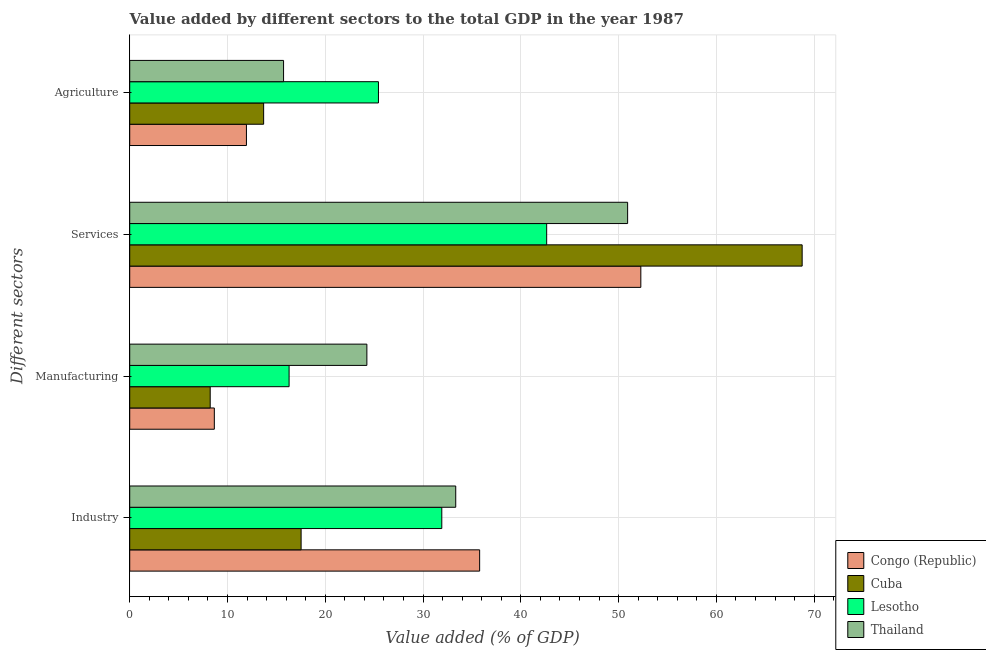How many different coloured bars are there?
Your answer should be very brief. 4. How many groups of bars are there?
Your answer should be very brief. 4. Are the number of bars on each tick of the Y-axis equal?
Your answer should be very brief. Yes. What is the label of the 4th group of bars from the top?
Ensure brevity in your answer.  Industry. What is the value added by agricultural sector in Cuba?
Offer a terse response. 13.7. Across all countries, what is the maximum value added by agricultural sector?
Offer a terse response. 25.44. Across all countries, what is the minimum value added by manufacturing sector?
Your response must be concise. 8.23. In which country was the value added by manufacturing sector maximum?
Offer a terse response. Thailand. In which country was the value added by industrial sector minimum?
Your answer should be compact. Cuba. What is the total value added by manufacturing sector in the graph?
Provide a succinct answer. 57.44. What is the difference between the value added by agricultural sector in Thailand and that in Lesotho?
Keep it short and to the point. -9.71. What is the difference between the value added by industrial sector in Cuba and the value added by manufacturing sector in Thailand?
Your answer should be compact. -6.73. What is the average value added by manufacturing sector per country?
Your response must be concise. 14.36. What is the difference between the value added by agricultural sector and value added by industrial sector in Lesotho?
Your answer should be compact. -6.48. What is the ratio of the value added by services sector in Thailand to that in Lesotho?
Make the answer very short. 1.19. Is the difference between the value added by services sector in Congo (Republic) and Thailand greater than the difference between the value added by manufacturing sector in Congo (Republic) and Thailand?
Provide a succinct answer. Yes. What is the difference between the highest and the second highest value added by industrial sector?
Your answer should be very brief. 2.45. What is the difference between the highest and the lowest value added by agricultural sector?
Your answer should be compact. 13.5. Is the sum of the value added by manufacturing sector in Cuba and Lesotho greater than the maximum value added by services sector across all countries?
Make the answer very short. No. Is it the case that in every country, the sum of the value added by manufacturing sector and value added by agricultural sector is greater than the sum of value added by services sector and value added by industrial sector?
Offer a very short reply. No. What does the 2nd bar from the top in Industry represents?
Provide a succinct answer. Lesotho. What does the 2nd bar from the bottom in Manufacturing represents?
Offer a very short reply. Cuba. Is it the case that in every country, the sum of the value added by industrial sector and value added by manufacturing sector is greater than the value added by services sector?
Offer a terse response. No. Are the values on the major ticks of X-axis written in scientific E-notation?
Ensure brevity in your answer.  No. Does the graph contain any zero values?
Provide a short and direct response. No. Does the graph contain grids?
Provide a short and direct response. Yes. Where does the legend appear in the graph?
Your response must be concise. Bottom right. How many legend labels are there?
Ensure brevity in your answer.  4. How are the legend labels stacked?
Your answer should be very brief. Vertical. What is the title of the graph?
Your answer should be compact. Value added by different sectors to the total GDP in the year 1987. Does "Kazakhstan" appear as one of the legend labels in the graph?
Your response must be concise. No. What is the label or title of the X-axis?
Make the answer very short. Value added (% of GDP). What is the label or title of the Y-axis?
Make the answer very short. Different sectors. What is the Value added (% of GDP) in Congo (Republic) in Industry?
Provide a short and direct response. 35.79. What is the Value added (% of GDP) in Cuba in Industry?
Provide a short and direct response. 17.53. What is the Value added (% of GDP) of Lesotho in Industry?
Offer a very short reply. 31.92. What is the Value added (% of GDP) of Thailand in Industry?
Keep it short and to the point. 33.34. What is the Value added (% of GDP) in Congo (Republic) in Manufacturing?
Make the answer very short. 8.65. What is the Value added (% of GDP) in Cuba in Manufacturing?
Ensure brevity in your answer.  8.23. What is the Value added (% of GDP) in Lesotho in Manufacturing?
Offer a very short reply. 16.3. What is the Value added (% of GDP) in Thailand in Manufacturing?
Provide a short and direct response. 24.25. What is the Value added (% of GDP) of Congo (Republic) in Services?
Your answer should be compact. 52.27. What is the Value added (% of GDP) in Cuba in Services?
Your answer should be compact. 68.77. What is the Value added (% of GDP) of Lesotho in Services?
Ensure brevity in your answer.  42.64. What is the Value added (% of GDP) in Thailand in Services?
Keep it short and to the point. 50.92. What is the Value added (% of GDP) in Congo (Republic) in Agriculture?
Offer a very short reply. 11.94. What is the Value added (% of GDP) of Cuba in Agriculture?
Offer a terse response. 13.7. What is the Value added (% of GDP) of Lesotho in Agriculture?
Keep it short and to the point. 25.44. What is the Value added (% of GDP) of Thailand in Agriculture?
Keep it short and to the point. 15.73. Across all Different sectors, what is the maximum Value added (% of GDP) in Congo (Republic)?
Offer a terse response. 52.27. Across all Different sectors, what is the maximum Value added (% of GDP) in Cuba?
Keep it short and to the point. 68.77. Across all Different sectors, what is the maximum Value added (% of GDP) in Lesotho?
Make the answer very short. 42.64. Across all Different sectors, what is the maximum Value added (% of GDP) of Thailand?
Your answer should be compact. 50.92. Across all Different sectors, what is the minimum Value added (% of GDP) of Congo (Republic)?
Offer a terse response. 8.65. Across all Different sectors, what is the minimum Value added (% of GDP) of Cuba?
Your response must be concise. 8.23. Across all Different sectors, what is the minimum Value added (% of GDP) of Lesotho?
Offer a terse response. 16.3. Across all Different sectors, what is the minimum Value added (% of GDP) in Thailand?
Your answer should be very brief. 15.73. What is the total Value added (% of GDP) in Congo (Republic) in the graph?
Ensure brevity in your answer.  108.65. What is the total Value added (% of GDP) in Cuba in the graph?
Ensure brevity in your answer.  108.23. What is the total Value added (% of GDP) in Lesotho in the graph?
Provide a succinct answer. 116.3. What is the total Value added (% of GDP) of Thailand in the graph?
Your response must be concise. 124.25. What is the difference between the Value added (% of GDP) in Congo (Republic) in Industry and that in Manufacturing?
Your answer should be very brief. 27.13. What is the difference between the Value added (% of GDP) in Cuba in Industry and that in Manufacturing?
Make the answer very short. 9.3. What is the difference between the Value added (% of GDP) of Lesotho in Industry and that in Manufacturing?
Your answer should be compact. 15.62. What is the difference between the Value added (% of GDP) of Thailand in Industry and that in Manufacturing?
Ensure brevity in your answer.  9.09. What is the difference between the Value added (% of GDP) of Congo (Republic) in Industry and that in Services?
Provide a succinct answer. -16.49. What is the difference between the Value added (% of GDP) of Cuba in Industry and that in Services?
Your answer should be very brief. -51.24. What is the difference between the Value added (% of GDP) of Lesotho in Industry and that in Services?
Your response must be concise. -10.73. What is the difference between the Value added (% of GDP) in Thailand in Industry and that in Services?
Offer a very short reply. -17.58. What is the difference between the Value added (% of GDP) of Congo (Republic) in Industry and that in Agriculture?
Offer a very short reply. 23.85. What is the difference between the Value added (% of GDP) in Cuba in Industry and that in Agriculture?
Give a very brief answer. 3.83. What is the difference between the Value added (% of GDP) in Lesotho in Industry and that in Agriculture?
Keep it short and to the point. 6.48. What is the difference between the Value added (% of GDP) of Thailand in Industry and that in Agriculture?
Give a very brief answer. 17.61. What is the difference between the Value added (% of GDP) in Congo (Republic) in Manufacturing and that in Services?
Give a very brief answer. -43.62. What is the difference between the Value added (% of GDP) in Cuba in Manufacturing and that in Services?
Offer a very short reply. -60.54. What is the difference between the Value added (% of GDP) in Lesotho in Manufacturing and that in Services?
Keep it short and to the point. -26.34. What is the difference between the Value added (% of GDP) of Thailand in Manufacturing and that in Services?
Provide a short and direct response. -26.67. What is the difference between the Value added (% of GDP) in Congo (Republic) in Manufacturing and that in Agriculture?
Your answer should be very brief. -3.28. What is the difference between the Value added (% of GDP) in Cuba in Manufacturing and that in Agriculture?
Your response must be concise. -5.47. What is the difference between the Value added (% of GDP) of Lesotho in Manufacturing and that in Agriculture?
Provide a succinct answer. -9.14. What is the difference between the Value added (% of GDP) of Thailand in Manufacturing and that in Agriculture?
Make the answer very short. 8.52. What is the difference between the Value added (% of GDP) in Congo (Republic) in Services and that in Agriculture?
Your answer should be compact. 40.34. What is the difference between the Value added (% of GDP) of Cuba in Services and that in Agriculture?
Give a very brief answer. 55.08. What is the difference between the Value added (% of GDP) of Lesotho in Services and that in Agriculture?
Offer a very short reply. 17.21. What is the difference between the Value added (% of GDP) in Thailand in Services and that in Agriculture?
Ensure brevity in your answer.  35.19. What is the difference between the Value added (% of GDP) of Congo (Republic) in Industry and the Value added (% of GDP) of Cuba in Manufacturing?
Ensure brevity in your answer.  27.56. What is the difference between the Value added (% of GDP) in Congo (Republic) in Industry and the Value added (% of GDP) in Lesotho in Manufacturing?
Your response must be concise. 19.49. What is the difference between the Value added (% of GDP) of Congo (Republic) in Industry and the Value added (% of GDP) of Thailand in Manufacturing?
Offer a terse response. 11.53. What is the difference between the Value added (% of GDP) of Cuba in Industry and the Value added (% of GDP) of Lesotho in Manufacturing?
Offer a very short reply. 1.23. What is the difference between the Value added (% of GDP) in Cuba in Industry and the Value added (% of GDP) in Thailand in Manufacturing?
Provide a succinct answer. -6.73. What is the difference between the Value added (% of GDP) of Lesotho in Industry and the Value added (% of GDP) of Thailand in Manufacturing?
Provide a succinct answer. 7.66. What is the difference between the Value added (% of GDP) in Congo (Republic) in Industry and the Value added (% of GDP) in Cuba in Services?
Ensure brevity in your answer.  -32.99. What is the difference between the Value added (% of GDP) of Congo (Republic) in Industry and the Value added (% of GDP) of Lesotho in Services?
Provide a short and direct response. -6.86. What is the difference between the Value added (% of GDP) of Congo (Republic) in Industry and the Value added (% of GDP) of Thailand in Services?
Provide a succinct answer. -15.14. What is the difference between the Value added (% of GDP) of Cuba in Industry and the Value added (% of GDP) of Lesotho in Services?
Offer a terse response. -25.11. What is the difference between the Value added (% of GDP) of Cuba in Industry and the Value added (% of GDP) of Thailand in Services?
Provide a short and direct response. -33.39. What is the difference between the Value added (% of GDP) in Lesotho in Industry and the Value added (% of GDP) in Thailand in Services?
Ensure brevity in your answer.  -19.01. What is the difference between the Value added (% of GDP) of Congo (Republic) in Industry and the Value added (% of GDP) of Cuba in Agriculture?
Provide a short and direct response. 22.09. What is the difference between the Value added (% of GDP) in Congo (Republic) in Industry and the Value added (% of GDP) in Lesotho in Agriculture?
Your answer should be very brief. 10.35. What is the difference between the Value added (% of GDP) in Congo (Republic) in Industry and the Value added (% of GDP) in Thailand in Agriculture?
Your answer should be very brief. 20.05. What is the difference between the Value added (% of GDP) in Cuba in Industry and the Value added (% of GDP) in Lesotho in Agriculture?
Provide a succinct answer. -7.91. What is the difference between the Value added (% of GDP) in Cuba in Industry and the Value added (% of GDP) in Thailand in Agriculture?
Your answer should be compact. 1.8. What is the difference between the Value added (% of GDP) of Lesotho in Industry and the Value added (% of GDP) of Thailand in Agriculture?
Your response must be concise. 16.18. What is the difference between the Value added (% of GDP) in Congo (Republic) in Manufacturing and the Value added (% of GDP) in Cuba in Services?
Your response must be concise. -60.12. What is the difference between the Value added (% of GDP) of Congo (Republic) in Manufacturing and the Value added (% of GDP) of Lesotho in Services?
Keep it short and to the point. -33.99. What is the difference between the Value added (% of GDP) of Congo (Republic) in Manufacturing and the Value added (% of GDP) of Thailand in Services?
Your answer should be compact. -42.27. What is the difference between the Value added (% of GDP) of Cuba in Manufacturing and the Value added (% of GDP) of Lesotho in Services?
Offer a very short reply. -34.41. What is the difference between the Value added (% of GDP) of Cuba in Manufacturing and the Value added (% of GDP) of Thailand in Services?
Ensure brevity in your answer.  -42.69. What is the difference between the Value added (% of GDP) in Lesotho in Manufacturing and the Value added (% of GDP) in Thailand in Services?
Provide a succinct answer. -34.62. What is the difference between the Value added (% of GDP) in Congo (Republic) in Manufacturing and the Value added (% of GDP) in Cuba in Agriculture?
Offer a terse response. -5.04. What is the difference between the Value added (% of GDP) in Congo (Republic) in Manufacturing and the Value added (% of GDP) in Lesotho in Agriculture?
Provide a short and direct response. -16.79. What is the difference between the Value added (% of GDP) of Congo (Republic) in Manufacturing and the Value added (% of GDP) of Thailand in Agriculture?
Your response must be concise. -7.08. What is the difference between the Value added (% of GDP) of Cuba in Manufacturing and the Value added (% of GDP) of Lesotho in Agriculture?
Your response must be concise. -17.21. What is the difference between the Value added (% of GDP) in Cuba in Manufacturing and the Value added (% of GDP) in Thailand in Agriculture?
Provide a short and direct response. -7.5. What is the difference between the Value added (% of GDP) of Lesotho in Manufacturing and the Value added (% of GDP) of Thailand in Agriculture?
Give a very brief answer. 0.57. What is the difference between the Value added (% of GDP) of Congo (Republic) in Services and the Value added (% of GDP) of Cuba in Agriculture?
Your response must be concise. 38.58. What is the difference between the Value added (% of GDP) of Congo (Republic) in Services and the Value added (% of GDP) of Lesotho in Agriculture?
Make the answer very short. 26.84. What is the difference between the Value added (% of GDP) of Congo (Republic) in Services and the Value added (% of GDP) of Thailand in Agriculture?
Ensure brevity in your answer.  36.54. What is the difference between the Value added (% of GDP) in Cuba in Services and the Value added (% of GDP) in Lesotho in Agriculture?
Keep it short and to the point. 43.34. What is the difference between the Value added (% of GDP) of Cuba in Services and the Value added (% of GDP) of Thailand in Agriculture?
Offer a very short reply. 53.04. What is the difference between the Value added (% of GDP) of Lesotho in Services and the Value added (% of GDP) of Thailand in Agriculture?
Offer a terse response. 26.91. What is the average Value added (% of GDP) of Congo (Republic) per Different sectors?
Your answer should be compact. 27.16. What is the average Value added (% of GDP) in Cuba per Different sectors?
Your answer should be very brief. 27.06. What is the average Value added (% of GDP) in Lesotho per Different sectors?
Keep it short and to the point. 29.08. What is the average Value added (% of GDP) in Thailand per Different sectors?
Offer a very short reply. 31.06. What is the difference between the Value added (% of GDP) in Congo (Republic) and Value added (% of GDP) in Cuba in Industry?
Give a very brief answer. 18.26. What is the difference between the Value added (% of GDP) of Congo (Republic) and Value added (% of GDP) of Lesotho in Industry?
Your answer should be compact. 3.87. What is the difference between the Value added (% of GDP) in Congo (Republic) and Value added (% of GDP) in Thailand in Industry?
Your answer should be very brief. 2.45. What is the difference between the Value added (% of GDP) in Cuba and Value added (% of GDP) in Lesotho in Industry?
Your answer should be compact. -14.39. What is the difference between the Value added (% of GDP) of Cuba and Value added (% of GDP) of Thailand in Industry?
Make the answer very short. -15.81. What is the difference between the Value added (% of GDP) of Lesotho and Value added (% of GDP) of Thailand in Industry?
Make the answer very short. -1.43. What is the difference between the Value added (% of GDP) of Congo (Republic) and Value added (% of GDP) of Cuba in Manufacturing?
Ensure brevity in your answer.  0.42. What is the difference between the Value added (% of GDP) of Congo (Republic) and Value added (% of GDP) of Lesotho in Manufacturing?
Give a very brief answer. -7.65. What is the difference between the Value added (% of GDP) in Congo (Republic) and Value added (% of GDP) in Thailand in Manufacturing?
Ensure brevity in your answer.  -15.6. What is the difference between the Value added (% of GDP) of Cuba and Value added (% of GDP) of Lesotho in Manufacturing?
Provide a short and direct response. -8.07. What is the difference between the Value added (% of GDP) in Cuba and Value added (% of GDP) in Thailand in Manufacturing?
Provide a short and direct response. -16.02. What is the difference between the Value added (% of GDP) of Lesotho and Value added (% of GDP) of Thailand in Manufacturing?
Provide a short and direct response. -7.95. What is the difference between the Value added (% of GDP) in Congo (Republic) and Value added (% of GDP) in Cuba in Services?
Give a very brief answer. -16.5. What is the difference between the Value added (% of GDP) in Congo (Republic) and Value added (% of GDP) in Lesotho in Services?
Make the answer very short. 9.63. What is the difference between the Value added (% of GDP) in Congo (Republic) and Value added (% of GDP) in Thailand in Services?
Offer a terse response. 1.35. What is the difference between the Value added (% of GDP) of Cuba and Value added (% of GDP) of Lesotho in Services?
Provide a short and direct response. 26.13. What is the difference between the Value added (% of GDP) in Cuba and Value added (% of GDP) in Thailand in Services?
Make the answer very short. 17.85. What is the difference between the Value added (% of GDP) in Lesotho and Value added (% of GDP) in Thailand in Services?
Your answer should be very brief. -8.28. What is the difference between the Value added (% of GDP) in Congo (Republic) and Value added (% of GDP) in Cuba in Agriculture?
Offer a terse response. -1.76. What is the difference between the Value added (% of GDP) in Congo (Republic) and Value added (% of GDP) in Lesotho in Agriculture?
Give a very brief answer. -13.5. What is the difference between the Value added (% of GDP) in Congo (Republic) and Value added (% of GDP) in Thailand in Agriculture?
Provide a succinct answer. -3.8. What is the difference between the Value added (% of GDP) of Cuba and Value added (% of GDP) of Lesotho in Agriculture?
Provide a short and direct response. -11.74. What is the difference between the Value added (% of GDP) in Cuba and Value added (% of GDP) in Thailand in Agriculture?
Keep it short and to the point. -2.04. What is the difference between the Value added (% of GDP) of Lesotho and Value added (% of GDP) of Thailand in Agriculture?
Give a very brief answer. 9.71. What is the ratio of the Value added (% of GDP) of Congo (Republic) in Industry to that in Manufacturing?
Make the answer very short. 4.14. What is the ratio of the Value added (% of GDP) of Cuba in Industry to that in Manufacturing?
Make the answer very short. 2.13. What is the ratio of the Value added (% of GDP) of Lesotho in Industry to that in Manufacturing?
Offer a terse response. 1.96. What is the ratio of the Value added (% of GDP) of Thailand in Industry to that in Manufacturing?
Offer a very short reply. 1.37. What is the ratio of the Value added (% of GDP) of Congo (Republic) in Industry to that in Services?
Offer a terse response. 0.68. What is the ratio of the Value added (% of GDP) in Cuba in Industry to that in Services?
Offer a very short reply. 0.25. What is the ratio of the Value added (% of GDP) of Lesotho in Industry to that in Services?
Make the answer very short. 0.75. What is the ratio of the Value added (% of GDP) in Thailand in Industry to that in Services?
Provide a succinct answer. 0.65. What is the ratio of the Value added (% of GDP) of Congo (Republic) in Industry to that in Agriculture?
Your response must be concise. 3. What is the ratio of the Value added (% of GDP) in Cuba in Industry to that in Agriculture?
Provide a succinct answer. 1.28. What is the ratio of the Value added (% of GDP) in Lesotho in Industry to that in Agriculture?
Give a very brief answer. 1.25. What is the ratio of the Value added (% of GDP) of Thailand in Industry to that in Agriculture?
Offer a very short reply. 2.12. What is the ratio of the Value added (% of GDP) in Congo (Republic) in Manufacturing to that in Services?
Your answer should be compact. 0.17. What is the ratio of the Value added (% of GDP) in Cuba in Manufacturing to that in Services?
Give a very brief answer. 0.12. What is the ratio of the Value added (% of GDP) in Lesotho in Manufacturing to that in Services?
Ensure brevity in your answer.  0.38. What is the ratio of the Value added (% of GDP) in Thailand in Manufacturing to that in Services?
Make the answer very short. 0.48. What is the ratio of the Value added (% of GDP) of Congo (Republic) in Manufacturing to that in Agriculture?
Offer a very short reply. 0.72. What is the ratio of the Value added (% of GDP) of Cuba in Manufacturing to that in Agriculture?
Provide a short and direct response. 0.6. What is the ratio of the Value added (% of GDP) in Lesotho in Manufacturing to that in Agriculture?
Provide a short and direct response. 0.64. What is the ratio of the Value added (% of GDP) of Thailand in Manufacturing to that in Agriculture?
Provide a short and direct response. 1.54. What is the ratio of the Value added (% of GDP) in Congo (Republic) in Services to that in Agriculture?
Make the answer very short. 4.38. What is the ratio of the Value added (% of GDP) of Cuba in Services to that in Agriculture?
Your answer should be compact. 5.02. What is the ratio of the Value added (% of GDP) in Lesotho in Services to that in Agriculture?
Keep it short and to the point. 1.68. What is the ratio of the Value added (% of GDP) of Thailand in Services to that in Agriculture?
Offer a terse response. 3.24. What is the difference between the highest and the second highest Value added (% of GDP) in Congo (Republic)?
Provide a succinct answer. 16.49. What is the difference between the highest and the second highest Value added (% of GDP) of Cuba?
Make the answer very short. 51.24. What is the difference between the highest and the second highest Value added (% of GDP) of Lesotho?
Make the answer very short. 10.73. What is the difference between the highest and the second highest Value added (% of GDP) in Thailand?
Keep it short and to the point. 17.58. What is the difference between the highest and the lowest Value added (% of GDP) in Congo (Republic)?
Provide a short and direct response. 43.62. What is the difference between the highest and the lowest Value added (% of GDP) of Cuba?
Give a very brief answer. 60.54. What is the difference between the highest and the lowest Value added (% of GDP) of Lesotho?
Keep it short and to the point. 26.34. What is the difference between the highest and the lowest Value added (% of GDP) of Thailand?
Give a very brief answer. 35.19. 